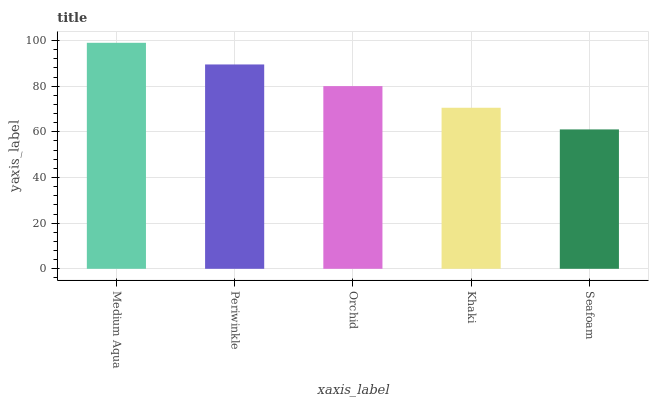Is Seafoam the minimum?
Answer yes or no. Yes. Is Medium Aqua the maximum?
Answer yes or no. Yes. Is Periwinkle the minimum?
Answer yes or no. No. Is Periwinkle the maximum?
Answer yes or no. No. Is Medium Aqua greater than Periwinkle?
Answer yes or no. Yes. Is Periwinkle less than Medium Aqua?
Answer yes or no. Yes. Is Periwinkle greater than Medium Aqua?
Answer yes or no. No. Is Medium Aqua less than Periwinkle?
Answer yes or no. No. Is Orchid the high median?
Answer yes or no. Yes. Is Orchid the low median?
Answer yes or no. Yes. Is Medium Aqua the high median?
Answer yes or no. No. Is Medium Aqua the low median?
Answer yes or no. No. 